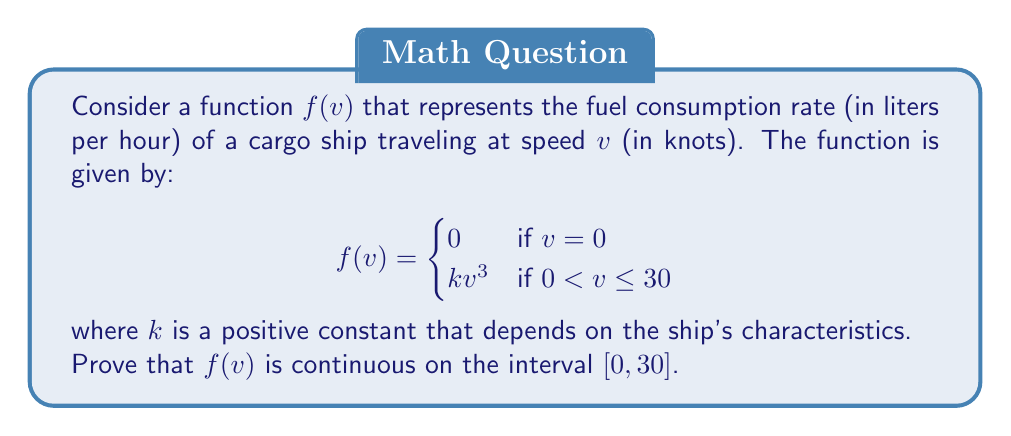Show me your answer to this math problem. To prove that $f(v)$ is continuous on the interval $[0, 30]$, we need to show that it is continuous at every point in this interval. We'll break this down into three parts:

1. Continuity at $v = 0$
2. Continuity on the open interval $(0, 30)$
3. Continuity at $v = 30$

1. Continuity at $v = 0$:
   To prove continuity at $v = 0$, we need to show that $\lim_{v \to 0^+} f(v) = f(0)$.

   $\lim_{v \to 0^+} f(v) = \lim_{v \to 0^+} kv^3 = k \cdot 0^3 = 0 = f(0)$

   Therefore, $f(v)$ is continuous at $v = 0$.

2. Continuity on $(0, 30)$:
   For $0 < v < 30$, $f(v) = kv^3$. This is a polynomial function, which is continuous for all real numbers. Therefore, $f(v)$ is continuous on the open interval $(0, 30)$.

3. Continuity at $v = 30$:
   To prove continuity at $v = 30$, we need to show that $\lim_{v \to 30^-} f(v) = f(30)$.

   $\lim_{v \to 30^-} f(v) = \lim_{v \to 30^-} kv^3 = k \cdot 30^3 = f(30)$

   Therefore, $f(v)$ is continuous at $v = 30$.

Since $f(v)$ is continuous at $v = 0$, on the open interval $(0, 30)$, and at $v = 30$, we can conclude that $f(v)$ is continuous on the entire closed interval $[0, 30]$.
Answer: The function $f(v)$ is continuous on the interval $[0, 30]$. 